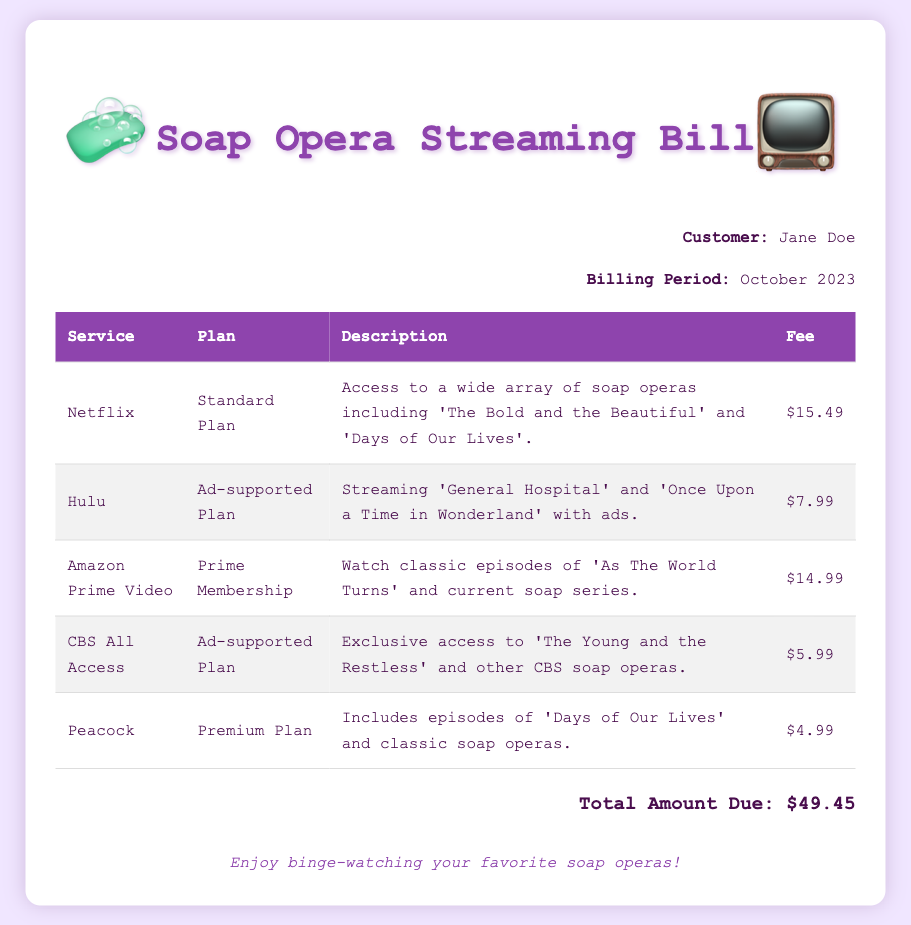What is the total amount due? The total amount due is calculated from the fees of all the services listed in the document.
Answer: $49.45 Who is the customer? The document identifies the person receiving the bill.
Answer: Jane Doe What is the billing period? The billing period indicates the time frame for which the services are being billed.
Answer: October 2023 Which streaming service provides 'The Young and the Restless'? This service is specifically mentioned in relation to its content offerings.
Answer: CBS All Access What is the fee for Hulu? The fee is listed next to the service in the table.
Answer: $7.99 How many services are listed in the document? The number of services is determined by counting the rows in the table.
Answer: 5 What plan does Netflix offer? The plan is specified in the service description in the document.
Answer: Standard Plan Which service has the lowest fee? The question requires comparing the fees listed for each service.
Answer: Peacock What type of plan does Amazon Prime Video have? The service type is indicated under the respective service in the bill.
Answer: Prime Membership 